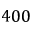<formula> <loc_0><loc_0><loc_500><loc_500>4 0 0</formula> 